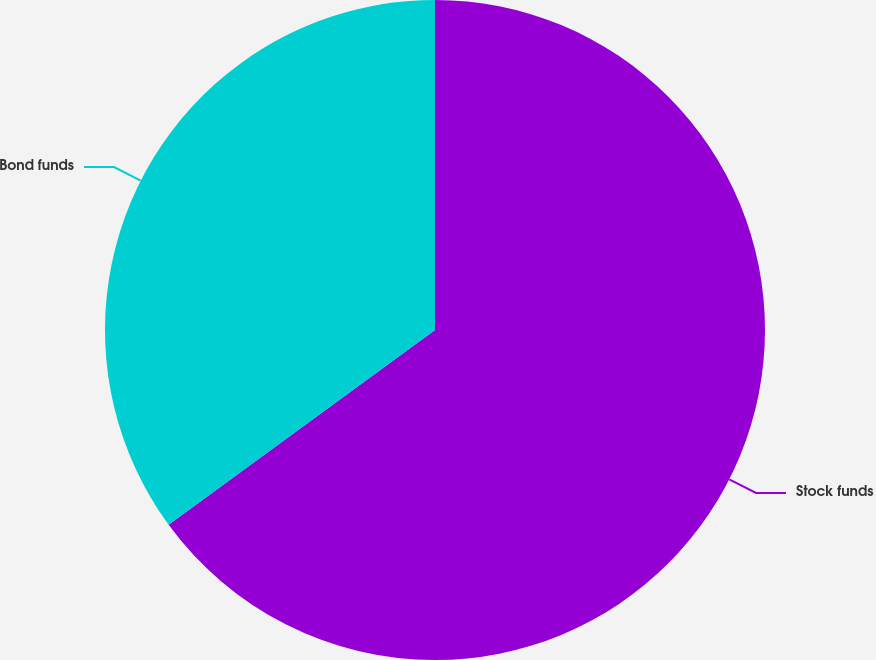<chart> <loc_0><loc_0><loc_500><loc_500><pie_chart><fcel>Stock funds<fcel>Bond funds<nl><fcel>64.95%<fcel>35.05%<nl></chart> 